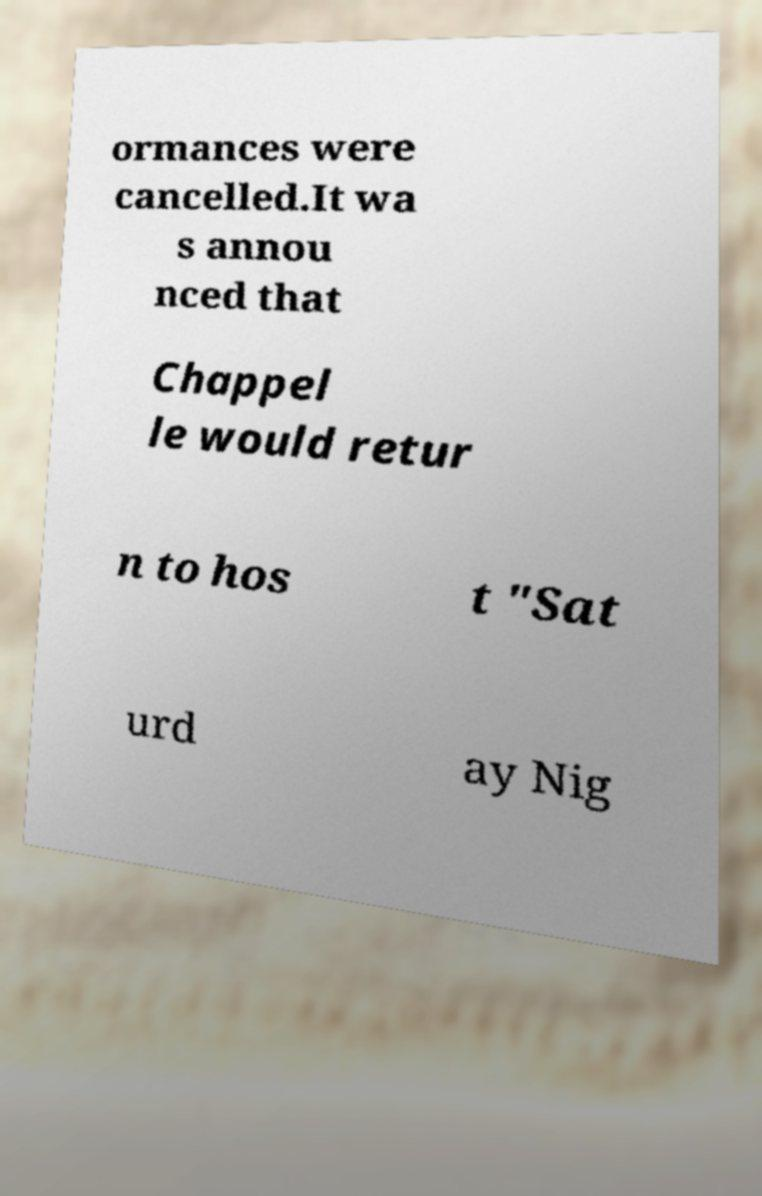Could you extract and type out the text from this image? ormances were cancelled.It wa s annou nced that Chappel le would retur n to hos t "Sat urd ay Nig 